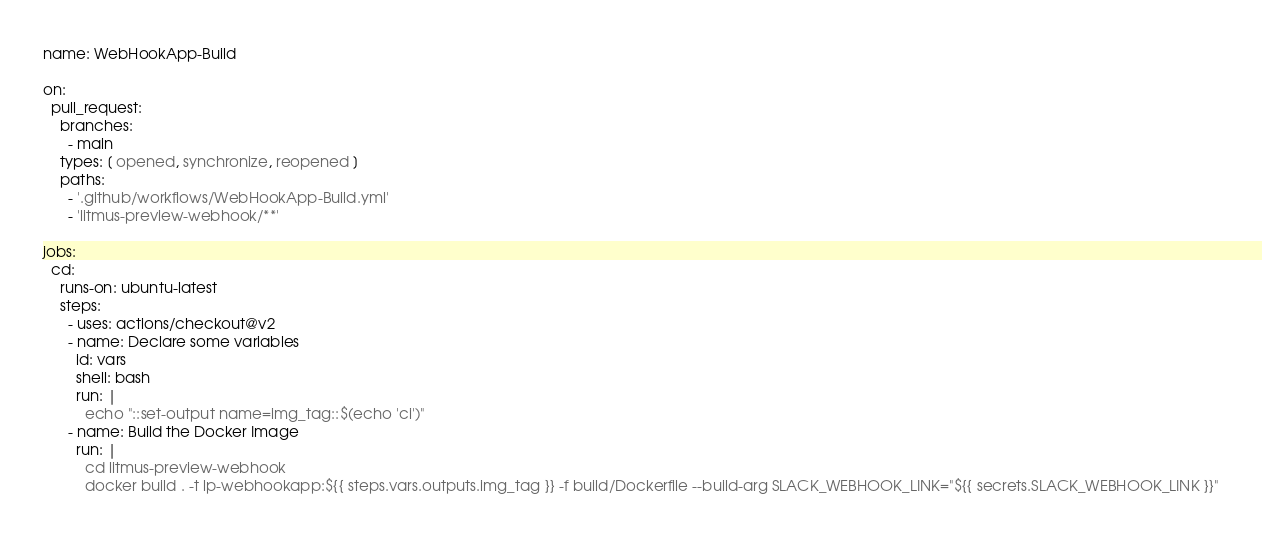<code> <loc_0><loc_0><loc_500><loc_500><_YAML_>name: WebHookApp-Build

on:
  pull_request:
    branches:
      - main
    types: [ opened, synchronize, reopened ]
    paths:
      - '.github/workflows/WebHookApp-Build.yml'
      - 'litmus-preview-webhook/**'

jobs:
  cd:
    runs-on: ubuntu-latest
    steps:
      - uses: actions/checkout@v2
      - name: Declare some variables
        id: vars
        shell: bash
        run: |
          echo "::set-output name=img_tag::$(echo 'ci')"
      - name: Build the Docker Image
        run: |
          cd litmus-preview-webhook
          docker build . -t lp-webhookapp:${{ steps.vars.outputs.img_tag }} -f build/Dockerfile --build-arg SLACK_WEBHOOK_LINK="${{ secrets.SLACK_WEBHOOK_LINK }}"</code> 